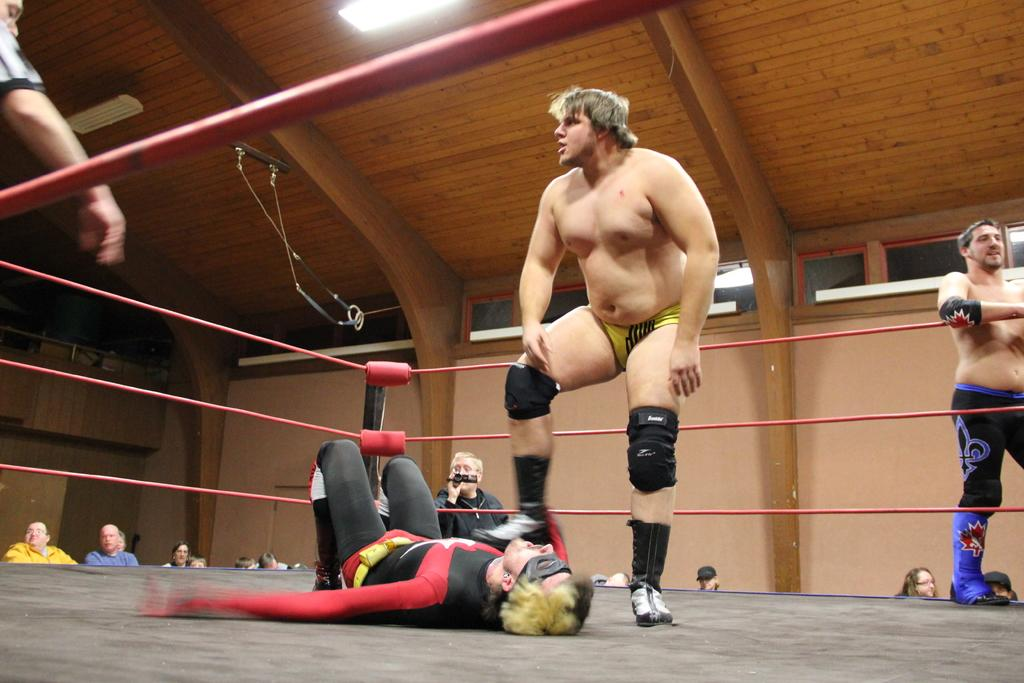How many people are in the image? There are people in the image, but the exact number is not specified. Where are some of the people located in the image? Some people are on a stage in the image. What can be seen in the background of the image? In the background, there is a red color rope, lights on the ceiling, walls, and other objects. Can you describe the lighting in the image? The lights on the ceiling provide illumination in the image. What time does the queen arrive in the image? There is no queen or specific time mentioned in the image. How does the person in the image feel about their crush? There is no information about a crush or any emotions in the image. 